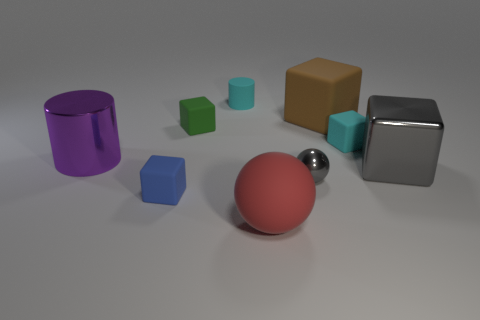Are there more large blocks than small blue cylinders?
Your answer should be compact. Yes. Do the brown block and the gray metal ball have the same size?
Offer a very short reply. No. How many things are spheres or big brown objects?
Your response must be concise. 3. What shape is the cyan thing that is behind the big matte object behind the big shiny thing in front of the purple object?
Your response must be concise. Cylinder. Is the material of the thing to the left of the blue thing the same as the brown object behind the metal ball?
Provide a succinct answer. No. What material is the big gray thing that is the same shape as the green thing?
Make the answer very short. Metal. Are there any other things that have the same size as the blue block?
Offer a terse response. Yes. Do the small matte object that is in front of the large purple shiny object and the tiny metallic thing that is behind the tiny blue cube have the same shape?
Your answer should be compact. No. Is the number of cyan cylinders on the right side of the small cylinder less than the number of cubes that are behind the large brown object?
Keep it short and to the point. No. How many other objects are there of the same shape as the large gray shiny object?
Provide a succinct answer. 4. 